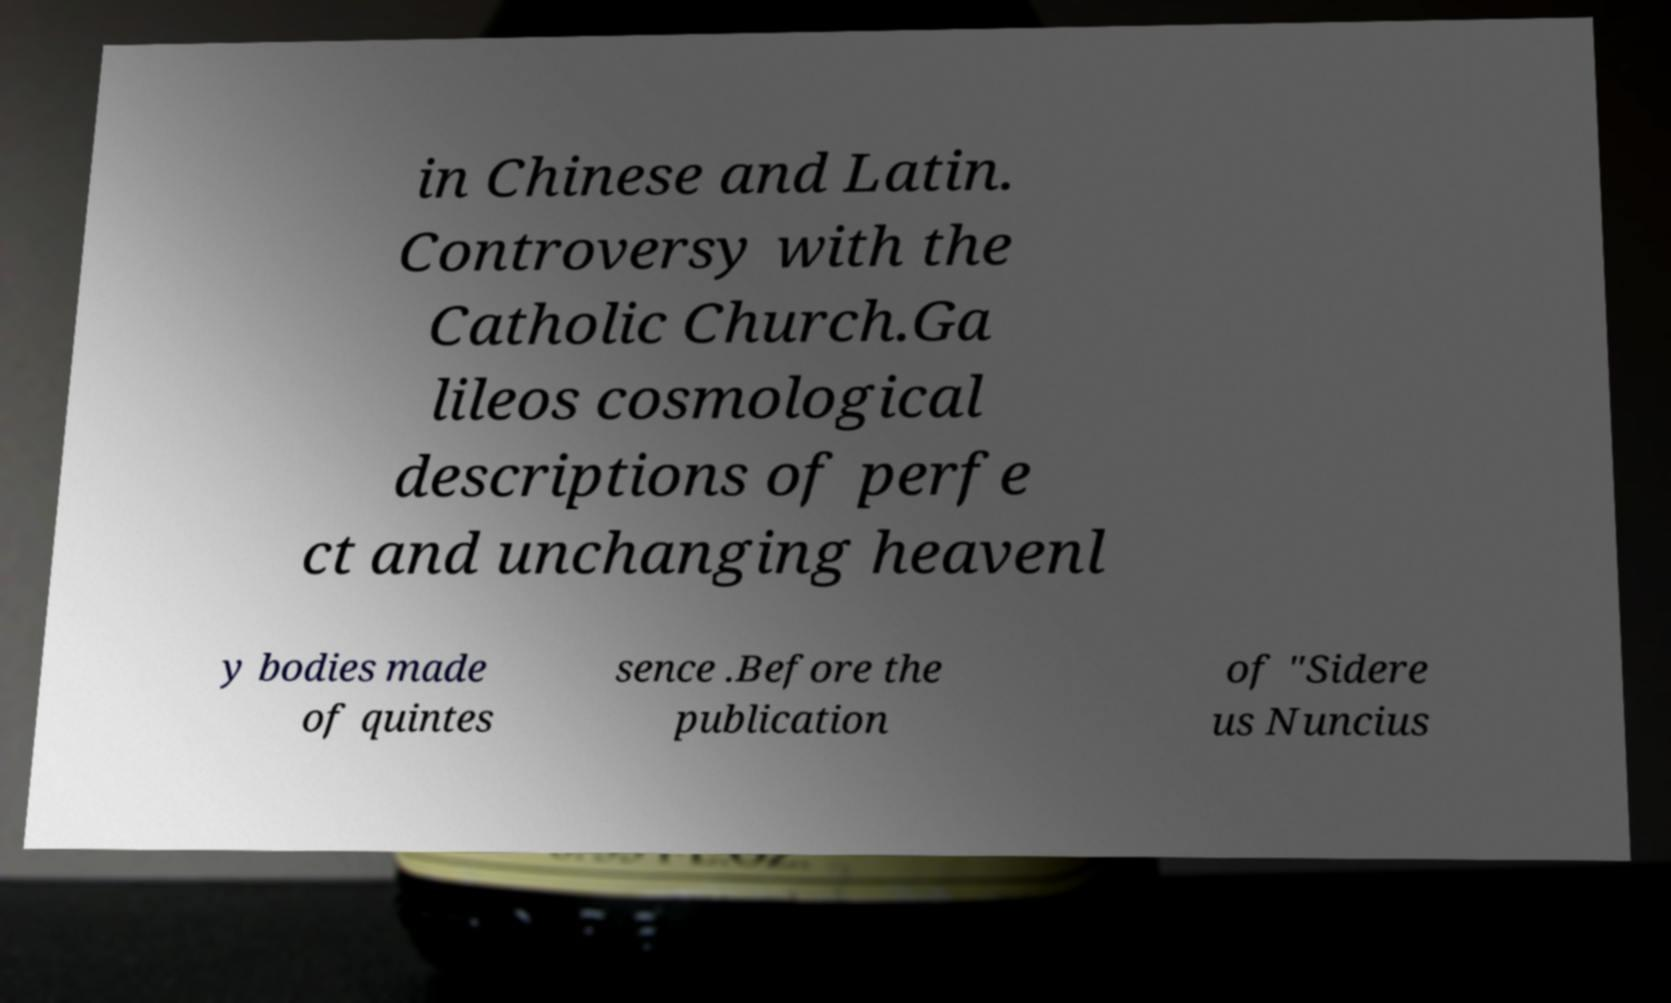I need the written content from this picture converted into text. Can you do that? in Chinese and Latin. Controversy with the Catholic Church.Ga lileos cosmological descriptions of perfe ct and unchanging heavenl y bodies made of quintes sence .Before the publication of "Sidere us Nuncius 